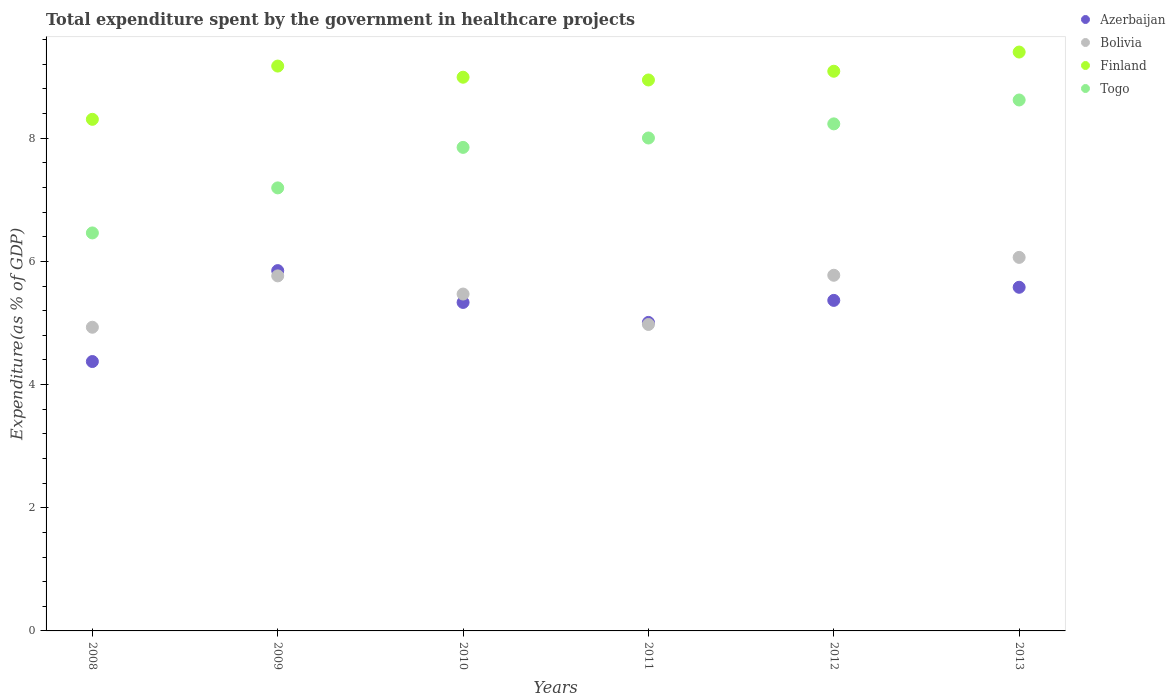How many different coloured dotlines are there?
Give a very brief answer. 4. What is the total expenditure spent by the government in healthcare projects in Togo in 2013?
Provide a succinct answer. 8.62. Across all years, what is the maximum total expenditure spent by the government in healthcare projects in Bolivia?
Offer a very short reply. 6.07. Across all years, what is the minimum total expenditure spent by the government in healthcare projects in Togo?
Your response must be concise. 6.46. In which year was the total expenditure spent by the government in healthcare projects in Bolivia minimum?
Make the answer very short. 2008. What is the total total expenditure spent by the government in healthcare projects in Togo in the graph?
Keep it short and to the point. 46.36. What is the difference between the total expenditure spent by the government in healthcare projects in Finland in 2008 and that in 2013?
Make the answer very short. -1.09. What is the difference between the total expenditure spent by the government in healthcare projects in Azerbaijan in 2013 and the total expenditure spent by the government in healthcare projects in Finland in 2008?
Provide a succinct answer. -2.73. What is the average total expenditure spent by the government in healthcare projects in Azerbaijan per year?
Your response must be concise. 5.25. In the year 2012, what is the difference between the total expenditure spent by the government in healthcare projects in Azerbaijan and total expenditure spent by the government in healthcare projects in Bolivia?
Provide a succinct answer. -0.41. In how many years, is the total expenditure spent by the government in healthcare projects in Finland greater than 1.6 %?
Keep it short and to the point. 6. What is the ratio of the total expenditure spent by the government in healthcare projects in Finland in 2008 to that in 2009?
Your response must be concise. 0.91. Is the total expenditure spent by the government in healthcare projects in Togo in 2010 less than that in 2012?
Make the answer very short. Yes. What is the difference between the highest and the second highest total expenditure spent by the government in healthcare projects in Bolivia?
Provide a succinct answer. 0.29. What is the difference between the highest and the lowest total expenditure spent by the government in healthcare projects in Finland?
Offer a very short reply. 1.09. In how many years, is the total expenditure spent by the government in healthcare projects in Togo greater than the average total expenditure spent by the government in healthcare projects in Togo taken over all years?
Ensure brevity in your answer.  4. Is the sum of the total expenditure spent by the government in healthcare projects in Togo in 2008 and 2010 greater than the maximum total expenditure spent by the government in healthcare projects in Bolivia across all years?
Your answer should be compact. Yes. Is it the case that in every year, the sum of the total expenditure spent by the government in healthcare projects in Finland and total expenditure spent by the government in healthcare projects in Bolivia  is greater than the total expenditure spent by the government in healthcare projects in Azerbaijan?
Provide a succinct answer. Yes. Does the total expenditure spent by the government in healthcare projects in Finland monotonically increase over the years?
Your answer should be compact. No. Is the total expenditure spent by the government in healthcare projects in Togo strictly greater than the total expenditure spent by the government in healthcare projects in Bolivia over the years?
Your answer should be compact. Yes. How many dotlines are there?
Your answer should be compact. 4. What is the difference between two consecutive major ticks on the Y-axis?
Give a very brief answer. 2. Are the values on the major ticks of Y-axis written in scientific E-notation?
Give a very brief answer. No. Does the graph contain any zero values?
Offer a very short reply. No. Does the graph contain grids?
Your answer should be very brief. No. Where does the legend appear in the graph?
Your answer should be compact. Top right. How many legend labels are there?
Offer a very short reply. 4. How are the legend labels stacked?
Offer a very short reply. Vertical. What is the title of the graph?
Offer a very short reply. Total expenditure spent by the government in healthcare projects. Does "Malaysia" appear as one of the legend labels in the graph?
Offer a terse response. No. What is the label or title of the X-axis?
Provide a succinct answer. Years. What is the label or title of the Y-axis?
Offer a very short reply. Expenditure(as % of GDP). What is the Expenditure(as % of GDP) in Azerbaijan in 2008?
Offer a very short reply. 4.37. What is the Expenditure(as % of GDP) in Bolivia in 2008?
Give a very brief answer. 4.93. What is the Expenditure(as % of GDP) of Finland in 2008?
Offer a very short reply. 8.31. What is the Expenditure(as % of GDP) of Togo in 2008?
Provide a succinct answer. 6.46. What is the Expenditure(as % of GDP) of Azerbaijan in 2009?
Provide a succinct answer. 5.85. What is the Expenditure(as % of GDP) of Bolivia in 2009?
Ensure brevity in your answer.  5.76. What is the Expenditure(as % of GDP) of Finland in 2009?
Keep it short and to the point. 9.17. What is the Expenditure(as % of GDP) of Togo in 2009?
Give a very brief answer. 7.19. What is the Expenditure(as % of GDP) in Azerbaijan in 2010?
Your answer should be very brief. 5.33. What is the Expenditure(as % of GDP) of Bolivia in 2010?
Provide a short and direct response. 5.47. What is the Expenditure(as % of GDP) of Finland in 2010?
Your answer should be compact. 8.99. What is the Expenditure(as % of GDP) of Togo in 2010?
Make the answer very short. 7.85. What is the Expenditure(as % of GDP) of Azerbaijan in 2011?
Your answer should be very brief. 5.01. What is the Expenditure(as % of GDP) of Bolivia in 2011?
Make the answer very short. 4.98. What is the Expenditure(as % of GDP) of Finland in 2011?
Ensure brevity in your answer.  8.95. What is the Expenditure(as % of GDP) in Togo in 2011?
Ensure brevity in your answer.  8. What is the Expenditure(as % of GDP) of Azerbaijan in 2012?
Offer a terse response. 5.37. What is the Expenditure(as % of GDP) in Bolivia in 2012?
Offer a terse response. 5.77. What is the Expenditure(as % of GDP) of Finland in 2012?
Ensure brevity in your answer.  9.09. What is the Expenditure(as % of GDP) in Togo in 2012?
Make the answer very short. 8.23. What is the Expenditure(as % of GDP) in Azerbaijan in 2013?
Your response must be concise. 5.58. What is the Expenditure(as % of GDP) of Bolivia in 2013?
Ensure brevity in your answer.  6.07. What is the Expenditure(as % of GDP) in Finland in 2013?
Ensure brevity in your answer.  9.4. What is the Expenditure(as % of GDP) in Togo in 2013?
Your answer should be very brief. 8.62. Across all years, what is the maximum Expenditure(as % of GDP) of Azerbaijan?
Offer a terse response. 5.85. Across all years, what is the maximum Expenditure(as % of GDP) of Bolivia?
Make the answer very short. 6.07. Across all years, what is the maximum Expenditure(as % of GDP) of Finland?
Make the answer very short. 9.4. Across all years, what is the maximum Expenditure(as % of GDP) in Togo?
Your answer should be very brief. 8.62. Across all years, what is the minimum Expenditure(as % of GDP) of Azerbaijan?
Your answer should be compact. 4.37. Across all years, what is the minimum Expenditure(as % of GDP) of Bolivia?
Your answer should be compact. 4.93. Across all years, what is the minimum Expenditure(as % of GDP) of Finland?
Your response must be concise. 8.31. Across all years, what is the minimum Expenditure(as % of GDP) of Togo?
Your answer should be compact. 6.46. What is the total Expenditure(as % of GDP) of Azerbaijan in the graph?
Make the answer very short. 31.51. What is the total Expenditure(as % of GDP) in Bolivia in the graph?
Ensure brevity in your answer.  32.98. What is the total Expenditure(as % of GDP) in Finland in the graph?
Provide a short and direct response. 53.9. What is the total Expenditure(as % of GDP) of Togo in the graph?
Give a very brief answer. 46.36. What is the difference between the Expenditure(as % of GDP) in Azerbaijan in 2008 and that in 2009?
Give a very brief answer. -1.48. What is the difference between the Expenditure(as % of GDP) of Bolivia in 2008 and that in 2009?
Your answer should be compact. -0.83. What is the difference between the Expenditure(as % of GDP) in Finland in 2008 and that in 2009?
Your response must be concise. -0.86. What is the difference between the Expenditure(as % of GDP) in Togo in 2008 and that in 2009?
Keep it short and to the point. -0.73. What is the difference between the Expenditure(as % of GDP) in Azerbaijan in 2008 and that in 2010?
Give a very brief answer. -0.96. What is the difference between the Expenditure(as % of GDP) of Bolivia in 2008 and that in 2010?
Provide a short and direct response. -0.54. What is the difference between the Expenditure(as % of GDP) of Finland in 2008 and that in 2010?
Ensure brevity in your answer.  -0.68. What is the difference between the Expenditure(as % of GDP) in Togo in 2008 and that in 2010?
Ensure brevity in your answer.  -1.39. What is the difference between the Expenditure(as % of GDP) of Azerbaijan in 2008 and that in 2011?
Your answer should be compact. -0.64. What is the difference between the Expenditure(as % of GDP) of Bolivia in 2008 and that in 2011?
Make the answer very short. -0.05. What is the difference between the Expenditure(as % of GDP) of Finland in 2008 and that in 2011?
Keep it short and to the point. -0.64. What is the difference between the Expenditure(as % of GDP) of Togo in 2008 and that in 2011?
Ensure brevity in your answer.  -1.54. What is the difference between the Expenditure(as % of GDP) of Azerbaijan in 2008 and that in 2012?
Ensure brevity in your answer.  -0.99. What is the difference between the Expenditure(as % of GDP) in Bolivia in 2008 and that in 2012?
Offer a very short reply. -0.84. What is the difference between the Expenditure(as % of GDP) in Finland in 2008 and that in 2012?
Give a very brief answer. -0.78. What is the difference between the Expenditure(as % of GDP) of Togo in 2008 and that in 2012?
Your answer should be compact. -1.77. What is the difference between the Expenditure(as % of GDP) in Azerbaijan in 2008 and that in 2013?
Offer a very short reply. -1.21. What is the difference between the Expenditure(as % of GDP) in Bolivia in 2008 and that in 2013?
Give a very brief answer. -1.13. What is the difference between the Expenditure(as % of GDP) in Finland in 2008 and that in 2013?
Give a very brief answer. -1.09. What is the difference between the Expenditure(as % of GDP) in Togo in 2008 and that in 2013?
Give a very brief answer. -2.16. What is the difference between the Expenditure(as % of GDP) in Azerbaijan in 2009 and that in 2010?
Make the answer very short. 0.52. What is the difference between the Expenditure(as % of GDP) in Bolivia in 2009 and that in 2010?
Keep it short and to the point. 0.29. What is the difference between the Expenditure(as % of GDP) of Finland in 2009 and that in 2010?
Your answer should be very brief. 0.18. What is the difference between the Expenditure(as % of GDP) in Togo in 2009 and that in 2010?
Your answer should be compact. -0.66. What is the difference between the Expenditure(as % of GDP) of Azerbaijan in 2009 and that in 2011?
Your answer should be very brief. 0.84. What is the difference between the Expenditure(as % of GDP) of Bolivia in 2009 and that in 2011?
Keep it short and to the point. 0.79. What is the difference between the Expenditure(as % of GDP) in Finland in 2009 and that in 2011?
Keep it short and to the point. 0.23. What is the difference between the Expenditure(as % of GDP) of Togo in 2009 and that in 2011?
Make the answer very short. -0.81. What is the difference between the Expenditure(as % of GDP) of Azerbaijan in 2009 and that in 2012?
Give a very brief answer. 0.48. What is the difference between the Expenditure(as % of GDP) in Bolivia in 2009 and that in 2012?
Offer a very short reply. -0.01. What is the difference between the Expenditure(as % of GDP) of Finland in 2009 and that in 2012?
Give a very brief answer. 0.08. What is the difference between the Expenditure(as % of GDP) in Togo in 2009 and that in 2012?
Provide a succinct answer. -1.04. What is the difference between the Expenditure(as % of GDP) in Azerbaijan in 2009 and that in 2013?
Make the answer very short. 0.27. What is the difference between the Expenditure(as % of GDP) in Bolivia in 2009 and that in 2013?
Offer a very short reply. -0.3. What is the difference between the Expenditure(as % of GDP) in Finland in 2009 and that in 2013?
Your response must be concise. -0.23. What is the difference between the Expenditure(as % of GDP) in Togo in 2009 and that in 2013?
Provide a succinct answer. -1.43. What is the difference between the Expenditure(as % of GDP) of Azerbaijan in 2010 and that in 2011?
Provide a short and direct response. 0.32. What is the difference between the Expenditure(as % of GDP) in Bolivia in 2010 and that in 2011?
Offer a terse response. 0.49. What is the difference between the Expenditure(as % of GDP) in Finland in 2010 and that in 2011?
Offer a terse response. 0.04. What is the difference between the Expenditure(as % of GDP) in Togo in 2010 and that in 2011?
Make the answer very short. -0.15. What is the difference between the Expenditure(as % of GDP) in Azerbaijan in 2010 and that in 2012?
Offer a very short reply. -0.03. What is the difference between the Expenditure(as % of GDP) of Bolivia in 2010 and that in 2012?
Your response must be concise. -0.3. What is the difference between the Expenditure(as % of GDP) in Finland in 2010 and that in 2012?
Offer a very short reply. -0.1. What is the difference between the Expenditure(as % of GDP) in Togo in 2010 and that in 2012?
Provide a short and direct response. -0.38. What is the difference between the Expenditure(as % of GDP) of Azerbaijan in 2010 and that in 2013?
Keep it short and to the point. -0.25. What is the difference between the Expenditure(as % of GDP) in Bolivia in 2010 and that in 2013?
Ensure brevity in your answer.  -0.6. What is the difference between the Expenditure(as % of GDP) of Finland in 2010 and that in 2013?
Your response must be concise. -0.41. What is the difference between the Expenditure(as % of GDP) in Togo in 2010 and that in 2013?
Ensure brevity in your answer.  -0.77. What is the difference between the Expenditure(as % of GDP) in Azerbaijan in 2011 and that in 2012?
Offer a terse response. -0.36. What is the difference between the Expenditure(as % of GDP) in Bolivia in 2011 and that in 2012?
Make the answer very short. -0.8. What is the difference between the Expenditure(as % of GDP) in Finland in 2011 and that in 2012?
Offer a terse response. -0.14. What is the difference between the Expenditure(as % of GDP) of Togo in 2011 and that in 2012?
Make the answer very short. -0.23. What is the difference between the Expenditure(as % of GDP) in Azerbaijan in 2011 and that in 2013?
Offer a very short reply. -0.57. What is the difference between the Expenditure(as % of GDP) of Bolivia in 2011 and that in 2013?
Offer a very short reply. -1.09. What is the difference between the Expenditure(as % of GDP) in Finland in 2011 and that in 2013?
Ensure brevity in your answer.  -0.45. What is the difference between the Expenditure(as % of GDP) in Togo in 2011 and that in 2013?
Ensure brevity in your answer.  -0.62. What is the difference between the Expenditure(as % of GDP) of Azerbaijan in 2012 and that in 2013?
Provide a short and direct response. -0.21. What is the difference between the Expenditure(as % of GDP) in Bolivia in 2012 and that in 2013?
Offer a terse response. -0.29. What is the difference between the Expenditure(as % of GDP) in Finland in 2012 and that in 2013?
Keep it short and to the point. -0.31. What is the difference between the Expenditure(as % of GDP) in Togo in 2012 and that in 2013?
Offer a terse response. -0.39. What is the difference between the Expenditure(as % of GDP) of Azerbaijan in 2008 and the Expenditure(as % of GDP) of Bolivia in 2009?
Offer a very short reply. -1.39. What is the difference between the Expenditure(as % of GDP) in Azerbaijan in 2008 and the Expenditure(as % of GDP) in Finland in 2009?
Provide a succinct answer. -4.8. What is the difference between the Expenditure(as % of GDP) in Azerbaijan in 2008 and the Expenditure(as % of GDP) in Togo in 2009?
Give a very brief answer. -2.82. What is the difference between the Expenditure(as % of GDP) of Bolivia in 2008 and the Expenditure(as % of GDP) of Finland in 2009?
Your answer should be compact. -4.24. What is the difference between the Expenditure(as % of GDP) of Bolivia in 2008 and the Expenditure(as % of GDP) of Togo in 2009?
Your response must be concise. -2.26. What is the difference between the Expenditure(as % of GDP) in Finland in 2008 and the Expenditure(as % of GDP) in Togo in 2009?
Your answer should be very brief. 1.11. What is the difference between the Expenditure(as % of GDP) of Azerbaijan in 2008 and the Expenditure(as % of GDP) of Bolivia in 2010?
Your answer should be compact. -1.1. What is the difference between the Expenditure(as % of GDP) of Azerbaijan in 2008 and the Expenditure(as % of GDP) of Finland in 2010?
Offer a very short reply. -4.62. What is the difference between the Expenditure(as % of GDP) of Azerbaijan in 2008 and the Expenditure(as % of GDP) of Togo in 2010?
Offer a very short reply. -3.48. What is the difference between the Expenditure(as % of GDP) of Bolivia in 2008 and the Expenditure(as % of GDP) of Finland in 2010?
Provide a short and direct response. -4.06. What is the difference between the Expenditure(as % of GDP) of Bolivia in 2008 and the Expenditure(as % of GDP) of Togo in 2010?
Your answer should be compact. -2.92. What is the difference between the Expenditure(as % of GDP) of Finland in 2008 and the Expenditure(as % of GDP) of Togo in 2010?
Make the answer very short. 0.46. What is the difference between the Expenditure(as % of GDP) in Azerbaijan in 2008 and the Expenditure(as % of GDP) in Bolivia in 2011?
Provide a short and direct response. -0.6. What is the difference between the Expenditure(as % of GDP) in Azerbaijan in 2008 and the Expenditure(as % of GDP) in Finland in 2011?
Make the answer very short. -4.57. What is the difference between the Expenditure(as % of GDP) of Azerbaijan in 2008 and the Expenditure(as % of GDP) of Togo in 2011?
Give a very brief answer. -3.63. What is the difference between the Expenditure(as % of GDP) of Bolivia in 2008 and the Expenditure(as % of GDP) of Finland in 2011?
Your answer should be very brief. -4.02. What is the difference between the Expenditure(as % of GDP) of Bolivia in 2008 and the Expenditure(as % of GDP) of Togo in 2011?
Your answer should be compact. -3.07. What is the difference between the Expenditure(as % of GDP) of Finland in 2008 and the Expenditure(as % of GDP) of Togo in 2011?
Provide a short and direct response. 0.3. What is the difference between the Expenditure(as % of GDP) of Azerbaijan in 2008 and the Expenditure(as % of GDP) of Bolivia in 2012?
Provide a short and direct response. -1.4. What is the difference between the Expenditure(as % of GDP) in Azerbaijan in 2008 and the Expenditure(as % of GDP) in Finland in 2012?
Provide a succinct answer. -4.71. What is the difference between the Expenditure(as % of GDP) of Azerbaijan in 2008 and the Expenditure(as % of GDP) of Togo in 2012?
Offer a very short reply. -3.86. What is the difference between the Expenditure(as % of GDP) of Bolivia in 2008 and the Expenditure(as % of GDP) of Finland in 2012?
Ensure brevity in your answer.  -4.16. What is the difference between the Expenditure(as % of GDP) in Bolivia in 2008 and the Expenditure(as % of GDP) in Togo in 2012?
Provide a short and direct response. -3.3. What is the difference between the Expenditure(as % of GDP) of Finland in 2008 and the Expenditure(as % of GDP) of Togo in 2012?
Offer a very short reply. 0.07. What is the difference between the Expenditure(as % of GDP) of Azerbaijan in 2008 and the Expenditure(as % of GDP) of Bolivia in 2013?
Offer a terse response. -1.69. What is the difference between the Expenditure(as % of GDP) in Azerbaijan in 2008 and the Expenditure(as % of GDP) in Finland in 2013?
Your answer should be very brief. -5.03. What is the difference between the Expenditure(as % of GDP) in Azerbaijan in 2008 and the Expenditure(as % of GDP) in Togo in 2013?
Ensure brevity in your answer.  -4.25. What is the difference between the Expenditure(as % of GDP) in Bolivia in 2008 and the Expenditure(as % of GDP) in Finland in 2013?
Offer a very short reply. -4.47. What is the difference between the Expenditure(as % of GDP) of Bolivia in 2008 and the Expenditure(as % of GDP) of Togo in 2013?
Ensure brevity in your answer.  -3.69. What is the difference between the Expenditure(as % of GDP) in Finland in 2008 and the Expenditure(as % of GDP) in Togo in 2013?
Keep it short and to the point. -0.31. What is the difference between the Expenditure(as % of GDP) in Azerbaijan in 2009 and the Expenditure(as % of GDP) in Bolivia in 2010?
Your answer should be compact. 0.38. What is the difference between the Expenditure(as % of GDP) of Azerbaijan in 2009 and the Expenditure(as % of GDP) of Finland in 2010?
Keep it short and to the point. -3.14. What is the difference between the Expenditure(as % of GDP) in Azerbaijan in 2009 and the Expenditure(as % of GDP) in Togo in 2010?
Make the answer very short. -2. What is the difference between the Expenditure(as % of GDP) in Bolivia in 2009 and the Expenditure(as % of GDP) in Finland in 2010?
Give a very brief answer. -3.23. What is the difference between the Expenditure(as % of GDP) in Bolivia in 2009 and the Expenditure(as % of GDP) in Togo in 2010?
Make the answer very short. -2.09. What is the difference between the Expenditure(as % of GDP) of Finland in 2009 and the Expenditure(as % of GDP) of Togo in 2010?
Provide a short and direct response. 1.32. What is the difference between the Expenditure(as % of GDP) in Azerbaijan in 2009 and the Expenditure(as % of GDP) in Bolivia in 2011?
Provide a succinct answer. 0.87. What is the difference between the Expenditure(as % of GDP) in Azerbaijan in 2009 and the Expenditure(as % of GDP) in Finland in 2011?
Your response must be concise. -3.1. What is the difference between the Expenditure(as % of GDP) of Azerbaijan in 2009 and the Expenditure(as % of GDP) of Togo in 2011?
Give a very brief answer. -2.15. What is the difference between the Expenditure(as % of GDP) of Bolivia in 2009 and the Expenditure(as % of GDP) of Finland in 2011?
Give a very brief answer. -3.18. What is the difference between the Expenditure(as % of GDP) of Bolivia in 2009 and the Expenditure(as % of GDP) of Togo in 2011?
Keep it short and to the point. -2.24. What is the difference between the Expenditure(as % of GDP) of Finland in 2009 and the Expenditure(as % of GDP) of Togo in 2011?
Your answer should be very brief. 1.17. What is the difference between the Expenditure(as % of GDP) in Azerbaijan in 2009 and the Expenditure(as % of GDP) in Bolivia in 2012?
Offer a very short reply. 0.08. What is the difference between the Expenditure(as % of GDP) of Azerbaijan in 2009 and the Expenditure(as % of GDP) of Finland in 2012?
Offer a terse response. -3.24. What is the difference between the Expenditure(as % of GDP) in Azerbaijan in 2009 and the Expenditure(as % of GDP) in Togo in 2012?
Provide a succinct answer. -2.38. What is the difference between the Expenditure(as % of GDP) in Bolivia in 2009 and the Expenditure(as % of GDP) in Finland in 2012?
Offer a terse response. -3.32. What is the difference between the Expenditure(as % of GDP) in Bolivia in 2009 and the Expenditure(as % of GDP) in Togo in 2012?
Offer a very short reply. -2.47. What is the difference between the Expenditure(as % of GDP) in Finland in 2009 and the Expenditure(as % of GDP) in Togo in 2012?
Keep it short and to the point. 0.94. What is the difference between the Expenditure(as % of GDP) in Azerbaijan in 2009 and the Expenditure(as % of GDP) in Bolivia in 2013?
Keep it short and to the point. -0.21. What is the difference between the Expenditure(as % of GDP) in Azerbaijan in 2009 and the Expenditure(as % of GDP) in Finland in 2013?
Provide a succinct answer. -3.55. What is the difference between the Expenditure(as % of GDP) of Azerbaijan in 2009 and the Expenditure(as % of GDP) of Togo in 2013?
Ensure brevity in your answer.  -2.77. What is the difference between the Expenditure(as % of GDP) of Bolivia in 2009 and the Expenditure(as % of GDP) of Finland in 2013?
Give a very brief answer. -3.63. What is the difference between the Expenditure(as % of GDP) of Bolivia in 2009 and the Expenditure(as % of GDP) of Togo in 2013?
Keep it short and to the point. -2.86. What is the difference between the Expenditure(as % of GDP) of Finland in 2009 and the Expenditure(as % of GDP) of Togo in 2013?
Offer a terse response. 0.55. What is the difference between the Expenditure(as % of GDP) in Azerbaijan in 2010 and the Expenditure(as % of GDP) in Bolivia in 2011?
Keep it short and to the point. 0.36. What is the difference between the Expenditure(as % of GDP) in Azerbaijan in 2010 and the Expenditure(as % of GDP) in Finland in 2011?
Give a very brief answer. -3.61. What is the difference between the Expenditure(as % of GDP) of Azerbaijan in 2010 and the Expenditure(as % of GDP) of Togo in 2011?
Keep it short and to the point. -2.67. What is the difference between the Expenditure(as % of GDP) of Bolivia in 2010 and the Expenditure(as % of GDP) of Finland in 2011?
Provide a short and direct response. -3.48. What is the difference between the Expenditure(as % of GDP) in Bolivia in 2010 and the Expenditure(as % of GDP) in Togo in 2011?
Make the answer very short. -2.53. What is the difference between the Expenditure(as % of GDP) in Finland in 2010 and the Expenditure(as % of GDP) in Togo in 2011?
Give a very brief answer. 0.99. What is the difference between the Expenditure(as % of GDP) of Azerbaijan in 2010 and the Expenditure(as % of GDP) of Bolivia in 2012?
Your answer should be very brief. -0.44. What is the difference between the Expenditure(as % of GDP) in Azerbaijan in 2010 and the Expenditure(as % of GDP) in Finland in 2012?
Provide a succinct answer. -3.75. What is the difference between the Expenditure(as % of GDP) in Azerbaijan in 2010 and the Expenditure(as % of GDP) in Togo in 2012?
Offer a terse response. -2.9. What is the difference between the Expenditure(as % of GDP) in Bolivia in 2010 and the Expenditure(as % of GDP) in Finland in 2012?
Offer a terse response. -3.62. What is the difference between the Expenditure(as % of GDP) of Bolivia in 2010 and the Expenditure(as % of GDP) of Togo in 2012?
Your response must be concise. -2.76. What is the difference between the Expenditure(as % of GDP) in Finland in 2010 and the Expenditure(as % of GDP) in Togo in 2012?
Make the answer very short. 0.76. What is the difference between the Expenditure(as % of GDP) in Azerbaijan in 2010 and the Expenditure(as % of GDP) in Bolivia in 2013?
Ensure brevity in your answer.  -0.73. What is the difference between the Expenditure(as % of GDP) in Azerbaijan in 2010 and the Expenditure(as % of GDP) in Finland in 2013?
Give a very brief answer. -4.07. What is the difference between the Expenditure(as % of GDP) of Azerbaijan in 2010 and the Expenditure(as % of GDP) of Togo in 2013?
Offer a very short reply. -3.29. What is the difference between the Expenditure(as % of GDP) of Bolivia in 2010 and the Expenditure(as % of GDP) of Finland in 2013?
Keep it short and to the point. -3.93. What is the difference between the Expenditure(as % of GDP) of Bolivia in 2010 and the Expenditure(as % of GDP) of Togo in 2013?
Keep it short and to the point. -3.15. What is the difference between the Expenditure(as % of GDP) of Finland in 2010 and the Expenditure(as % of GDP) of Togo in 2013?
Make the answer very short. 0.37. What is the difference between the Expenditure(as % of GDP) in Azerbaijan in 2011 and the Expenditure(as % of GDP) in Bolivia in 2012?
Make the answer very short. -0.77. What is the difference between the Expenditure(as % of GDP) of Azerbaijan in 2011 and the Expenditure(as % of GDP) of Finland in 2012?
Offer a very short reply. -4.08. What is the difference between the Expenditure(as % of GDP) in Azerbaijan in 2011 and the Expenditure(as % of GDP) in Togo in 2012?
Keep it short and to the point. -3.22. What is the difference between the Expenditure(as % of GDP) of Bolivia in 2011 and the Expenditure(as % of GDP) of Finland in 2012?
Offer a very short reply. -4.11. What is the difference between the Expenditure(as % of GDP) in Bolivia in 2011 and the Expenditure(as % of GDP) in Togo in 2012?
Your answer should be compact. -3.26. What is the difference between the Expenditure(as % of GDP) in Finland in 2011 and the Expenditure(as % of GDP) in Togo in 2012?
Offer a very short reply. 0.71. What is the difference between the Expenditure(as % of GDP) in Azerbaijan in 2011 and the Expenditure(as % of GDP) in Bolivia in 2013?
Provide a short and direct response. -1.06. What is the difference between the Expenditure(as % of GDP) in Azerbaijan in 2011 and the Expenditure(as % of GDP) in Finland in 2013?
Your response must be concise. -4.39. What is the difference between the Expenditure(as % of GDP) in Azerbaijan in 2011 and the Expenditure(as % of GDP) in Togo in 2013?
Provide a short and direct response. -3.61. What is the difference between the Expenditure(as % of GDP) of Bolivia in 2011 and the Expenditure(as % of GDP) of Finland in 2013?
Keep it short and to the point. -4.42. What is the difference between the Expenditure(as % of GDP) in Bolivia in 2011 and the Expenditure(as % of GDP) in Togo in 2013?
Offer a very short reply. -3.64. What is the difference between the Expenditure(as % of GDP) in Finland in 2011 and the Expenditure(as % of GDP) in Togo in 2013?
Keep it short and to the point. 0.33. What is the difference between the Expenditure(as % of GDP) of Azerbaijan in 2012 and the Expenditure(as % of GDP) of Bolivia in 2013?
Provide a succinct answer. -0.7. What is the difference between the Expenditure(as % of GDP) of Azerbaijan in 2012 and the Expenditure(as % of GDP) of Finland in 2013?
Your answer should be very brief. -4.03. What is the difference between the Expenditure(as % of GDP) of Azerbaijan in 2012 and the Expenditure(as % of GDP) of Togo in 2013?
Make the answer very short. -3.25. What is the difference between the Expenditure(as % of GDP) of Bolivia in 2012 and the Expenditure(as % of GDP) of Finland in 2013?
Your answer should be compact. -3.62. What is the difference between the Expenditure(as % of GDP) in Bolivia in 2012 and the Expenditure(as % of GDP) in Togo in 2013?
Offer a terse response. -2.85. What is the difference between the Expenditure(as % of GDP) in Finland in 2012 and the Expenditure(as % of GDP) in Togo in 2013?
Provide a short and direct response. 0.47. What is the average Expenditure(as % of GDP) of Azerbaijan per year?
Make the answer very short. 5.25. What is the average Expenditure(as % of GDP) of Bolivia per year?
Offer a terse response. 5.5. What is the average Expenditure(as % of GDP) in Finland per year?
Offer a very short reply. 8.98. What is the average Expenditure(as % of GDP) of Togo per year?
Your answer should be compact. 7.73. In the year 2008, what is the difference between the Expenditure(as % of GDP) of Azerbaijan and Expenditure(as % of GDP) of Bolivia?
Keep it short and to the point. -0.56. In the year 2008, what is the difference between the Expenditure(as % of GDP) of Azerbaijan and Expenditure(as % of GDP) of Finland?
Keep it short and to the point. -3.93. In the year 2008, what is the difference between the Expenditure(as % of GDP) of Azerbaijan and Expenditure(as % of GDP) of Togo?
Offer a very short reply. -2.09. In the year 2008, what is the difference between the Expenditure(as % of GDP) in Bolivia and Expenditure(as % of GDP) in Finland?
Offer a very short reply. -3.38. In the year 2008, what is the difference between the Expenditure(as % of GDP) in Bolivia and Expenditure(as % of GDP) in Togo?
Provide a short and direct response. -1.53. In the year 2008, what is the difference between the Expenditure(as % of GDP) in Finland and Expenditure(as % of GDP) in Togo?
Make the answer very short. 1.84. In the year 2009, what is the difference between the Expenditure(as % of GDP) in Azerbaijan and Expenditure(as % of GDP) in Bolivia?
Provide a short and direct response. 0.09. In the year 2009, what is the difference between the Expenditure(as % of GDP) in Azerbaijan and Expenditure(as % of GDP) in Finland?
Provide a short and direct response. -3.32. In the year 2009, what is the difference between the Expenditure(as % of GDP) in Azerbaijan and Expenditure(as % of GDP) in Togo?
Your answer should be compact. -1.34. In the year 2009, what is the difference between the Expenditure(as % of GDP) of Bolivia and Expenditure(as % of GDP) of Finland?
Offer a very short reply. -3.41. In the year 2009, what is the difference between the Expenditure(as % of GDP) in Bolivia and Expenditure(as % of GDP) in Togo?
Your answer should be very brief. -1.43. In the year 2009, what is the difference between the Expenditure(as % of GDP) of Finland and Expenditure(as % of GDP) of Togo?
Your answer should be very brief. 1.98. In the year 2010, what is the difference between the Expenditure(as % of GDP) in Azerbaijan and Expenditure(as % of GDP) in Bolivia?
Your answer should be very brief. -0.14. In the year 2010, what is the difference between the Expenditure(as % of GDP) of Azerbaijan and Expenditure(as % of GDP) of Finland?
Your answer should be very brief. -3.66. In the year 2010, what is the difference between the Expenditure(as % of GDP) of Azerbaijan and Expenditure(as % of GDP) of Togo?
Make the answer very short. -2.52. In the year 2010, what is the difference between the Expenditure(as % of GDP) of Bolivia and Expenditure(as % of GDP) of Finland?
Provide a short and direct response. -3.52. In the year 2010, what is the difference between the Expenditure(as % of GDP) in Bolivia and Expenditure(as % of GDP) in Togo?
Ensure brevity in your answer.  -2.38. In the year 2010, what is the difference between the Expenditure(as % of GDP) in Finland and Expenditure(as % of GDP) in Togo?
Make the answer very short. 1.14. In the year 2011, what is the difference between the Expenditure(as % of GDP) in Azerbaijan and Expenditure(as % of GDP) in Bolivia?
Your response must be concise. 0.03. In the year 2011, what is the difference between the Expenditure(as % of GDP) of Azerbaijan and Expenditure(as % of GDP) of Finland?
Keep it short and to the point. -3.94. In the year 2011, what is the difference between the Expenditure(as % of GDP) of Azerbaijan and Expenditure(as % of GDP) of Togo?
Provide a succinct answer. -2.99. In the year 2011, what is the difference between the Expenditure(as % of GDP) in Bolivia and Expenditure(as % of GDP) in Finland?
Your answer should be compact. -3.97. In the year 2011, what is the difference between the Expenditure(as % of GDP) of Bolivia and Expenditure(as % of GDP) of Togo?
Your response must be concise. -3.03. In the year 2011, what is the difference between the Expenditure(as % of GDP) in Finland and Expenditure(as % of GDP) in Togo?
Provide a succinct answer. 0.94. In the year 2012, what is the difference between the Expenditure(as % of GDP) in Azerbaijan and Expenditure(as % of GDP) in Bolivia?
Your answer should be very brief. -0.41. In the year 2012, what is the difference between the Expenditure(as % of GDP) in Azerbaijan and Expenditure(as % of GDP) in Finland?
Your answer should be very brief. -3.72. In the year 2012, what is the difference between the Expenditure(as % of GDP) of Azerbaijan and Expenditure(as % of GDP) of Togo?
Offer a terse response. -2.87. In the year 2012, what is the difference between the Expenditure(as % of GDP) in Bolivia and Expenditure(as % of GDP) in Finland?
Provide a short and direct response. -3.31. In the year 2012, what is the difference between the Expenditure(as % of GDP) of Bolivia and Expenditure(as % of GDP) of Togo?
Your response must be concise. -2.46. In the year 2012, what is the difference between the Expenditure(as % of GDP) of Finland and Expenditure(as % of GDP) of Togo?
Provide a succinct answer. 0.85. In the year 2013, what is the difference between the Expenditure(as % of GDP) in Azerbaijan and Expenditure(as % of GDP) in Bolivia?
Your answer should be compact. -0.49. In the year 2013, what is the difference between the Expenditure(as % of GDP) in Azerbaijan and Expenditure(as % of GDP) in Finland?
Provide a succinct answer. -3.82. In the year 2013, what is the difference between the Expenditure(as % of GDP) of Azerbaijan and Expenditure(as % of GDP) of Togo?
Your answer should be compact. -3.04. In the year 2013, what is the difference between the Expenditure(as % of GDP) in Bolivia and Expenditure(as % of GDP) in Finland?
Make the answer very short. -3.33. In the year 2013, what is the difference between the Expenditure(as % of GDP) of Bolivia and Expenditure(as % of GDP) of Togo?
Offer a terse response. -2.56. In the year 2013, what is the difference between the Expenditure(as % of GDP) of Finland and Expenditure(as % of GDP) of Togo?
Keep it short and to the point. 0.78. What is the ratio of the Expenditure(as % of GDP) of Azerbaijan in 2008 to that in 2009?
Your answer should be compact. 0.75. What is the ratio of the Expenditure(as % of GDP) in Bolivia in 2008 to that in 2009?
Your answer should be compact. 0.86. What is the ratio of the Expenditure(as % of GDP) of Finland in 2008 to that in 2009?
Make the answer very short. 0.91. What is the ratio of the Expenditure(as % of GDP) in Togo in 2008 to that in 2009?
Ensure brevity in your answer.  0.9. What is the ratio of the Expenditure(as % of GDP) of Azerbaijan in 2008 to that in 2010?
Your answer should be very brief. 0.82. What is the ratio of the Expenditure(as % of GDP) of Bolivia in 2008 to that in 2010?
Your answer should be very brief. 0.9. What is the ratio of the Expenditure(as % of GDP) of Finland in 2008 to that in 2010?
Offer a terse response. 0.92. What is the ratio of the Expenditure(as % of GDP) in Togo in 2008 to that in 2010?
Your response must be concise. 0.82. What is the ratio of the Expenditure(as % of GDP) of Azerbaijan in 2008 to that in 2011?
Ensure brevity in your answer.  0.87. What is the ratio of the Expenditure(as % of GDP) of Bolivia in 2008 to that in 2011?
Provide a short and direct response. 0.99. What is the ratio of the Expenditure(as % of GDP) of Togo in 2008 to that in 2011?
Your response must be concise. 0.81. What is the ratio of the Expenditure(as % of GDP) in Azerbaijan in 2008 to that in 2012?
Ensure brevity in your answer.  0.81. What is the ratio of the Expenditure(as % of GDP) of Bolivia in 2008 to that in 2012?
Provide a succinct answer. 0.85. What is the ratio of the Expenditure(as % of GDP) of Finland in 2008 to that in 2012?
Ensure brevity in your answer.  0.91. What is the ratio of the Expenditure(as % of GDP) in Togo in 2008 to that in 2012?
Keep it short and to the point. 0.78. What is the ratio of the Expenditure(as % of GDP) in Azerbaijan in 2008 to that in 2013?
Provide a succinct answer. 0.78. What is the ratio of the Expenditure(as % of GDP) of Bolivia in 2008 to that in 2013?
Ensure brevity in your answer.  0.81. What is the ratio of the Expenditure(as % of GDP) in Finland in 2008 to that in 2013?
Ensure brevity in your answer.  0.88. What is the ratio of the Expenditure(as % of GDP) in Togo in 2008 to that in 2013?
Keep it short and to the point. 0.75. What is the ratio of the Expenditure(as % of GDP) in Azerbaijan in 2009 to that in 2010?
Offer a terse response. 1.1. What is the ratio of the Expenditure(as % of GDP) of Bolivia in 2009 to that in 2010?
Offer a terse response. 1.05. What is the ratio of the Expenditure(as % of GDP) of Finland in 2009 to that in 2010?
Offer a terse response. 1.02. What is the ratio of the Expenditure(as % of GDP) in Togo in 2009 to that in 2010?
Your answer should be very brief. 0.92. What is the ratio of the Expenditure(as % of GDP) of Azerbaijan in 2009 to that in 2011?
Keep it short and to the point. 1.17. What is the ratio of the Expenditure(as % of GDP) in Bolivia in 2009 to that in 2011?
Give a very brief answer. 1.16. What is the ratio of the Expenditure(as % of GDP) in Finland in 2009 to that in 2011?
Keep it short and to the point. 1.03. What is the ratio of the Expenditure(as % of GDP) in Togo in 2009 to that in 2011?
Your answer should be very brief. 0.9. What is the ratio of the Expenditure(as % of GDP) in Azerbaijan in 2009 to that in 2012?
Your response must be concise. 1.09. What is the ratio of the Expenditure(as % of GDP) of Bolivia in 2009 to that in 2012?
Your answer should be compact. 1. What is the ratio of the Expenditure(as % of GDP) of Finland in 2009 to that in 2012?
Give a very brief answer. 1.01. What is the ratio of the Expenditure(as % of GDP) in Togo in 2009 to that in 2012?
Provide a short and direct response. 0.87. What is the ratio of the Expenditure(as % of GDP) of Azerbaijan in 2009 to that in 2013?
Give a very brief answer. 1.05. What is the ratio of the Expenditure(as % of GDP) of Bolivia in 2009 to that in 2013?
Your answer should be compact. 0.95. What is the ratio of the Expenditure(as % of GDP) in Finland in 2009 to that in 2013?
Provide a short and direct response. 0.98. What is the ratio of the Expenditure(as % of GDP) of Togo in 2009 to that in 2013?
Give a very brief answer. 0.83. What is the ratio of the Expenditure(as % of GDP) in Azerbaijan in 2010 to that in 2011?
Keep it short and to the point. 1.06. What is the ratio of the Expenditure(as % of GDP) in Bolivia in 2010 to that in 2011?
Ensure brevity in your answer.  1.1. What is the ratio of the Expenditure(as % of GDP) of Togo in 2010 to that in 2011?
Offer a terse response. 0.98. What is the ratio of the Expenditure(as % of GDP) in Bolivia in 2010 to that in 2012?
Give a very brief answer. 0.95. What is the ratio of the Expenditure(as % of GDP) of Finland in 2010 to that in 2012?
Ensure brevity in your answer.  0.99. What is the ratio of the Expenditure(as % of GDP) of Togo in 2010 to that in 2012?
Provide a short and direct response. 0.95. What is the ratio of the Expenditure(as % of GDP) of Azerbaijan in 2010 to that in 2013?
Offer a very short reply. 0.96. What is the ratio of the Expenditure(as % of GDP) of Bolivia in 2010 to that in 2013?
Ensure brevity in your answer.  0.9. What is the ratio of the Expenditure(as % of GDP) of Finland in 2010 to that in 2013?
Provide a succinct answer. 0.96. What is the ratio of the Expenditure(as % of GDP) in Togo in 2010 to that in 2013?
Provide a succinct answer. 0.91. What is the ratio of the Expenditure(as % of GDP) in Azerbaijan in 2011 to that in 2012?
Your response must be concise. 0.93. What is the ratio of the Expenditure(as % of GDP) of Bolivia in 2011 to that in 2012?
Your answer should be very brief. 0.86. What is the ratio of the Expenditure(as % of GDP) in Finland in 2011 to that in 2012?
Make the answer very short. 0.98. What is the ratio of the Expenditure(as % of GDP) in Togo in 2011 to that in 2012?
Provide a succinct answer. 0.97. What is the ratio of the Expenditure(as % of GDP) in Azerbaijan in 2011 to that in 2013?
Your answer should be compact. 0.9. What is the ratio of the Expenditure(as % of GDP) in Bolivia in 2011 to that in 2013?
Ensure brevity in your answer.  0.82. What is the ratio of the Expenditure(as % of GDP) in Finland in 2011 to that in 2013?
Ensure brevity in your answer.  0.95. What is the ratio of the Expenditure(as % of GDP) of Togo in 2011 to that in 2013?
Offer a very short reply. 0.93. What is the ratio of the Expenditure(as % of GDP) of Azerbaijan in 2012 to that in 2013?
Provide a succinct answer. 0.96. What is the ratio of the Expenditure(as % of GDP) in Bolivia in 2012 to that in 2013?
Offer a very short reply. 0.95. What is the ratio of the Expenditure(as % of GDP) in Finland in 2012 to that in 2013?
Offer a very short reply. 0.97. What is the ratio of the Expenditure(as % of GDP) of Togo in 2012 to that in 2013?
Your response must be concise. 0.95. What is the difference between the highest and the second highest Expenditure(as % of GDP) in Azerbaijan?
Keep it short and to the point. 0.27. What is the difference between the highest and the second highest Expenditure(as % of GDP) of Bolivia?
Offer a terse response. 0.29. What is the difference between the highest and the second highest Expenditure(as % of GDP) in Finland?
Provide a succinct answer. 0.23. What is the difference between the highest and the second highest Expenditure(as % of GDP) in Togo?
Your answer should be very brief. 0.39. What is the difference between the highest and the lowest Expenditure(as % of GDP) of Azerbaijan?
Keep it short and to the point. 1.48. What is the difference between the highest and the lowest Expenditure(as % of GDP) in Bolivia?
Your answer should be compact. 1.13. What is the difference between the highest and the lowest Expenditure(as % of GDP) of Finland?
Give a very brief answer. 1.09. What is the difference between the highest and the lowest Expenditure(as % of GDP) of Togo?
Offer a terse response. 2.16. 